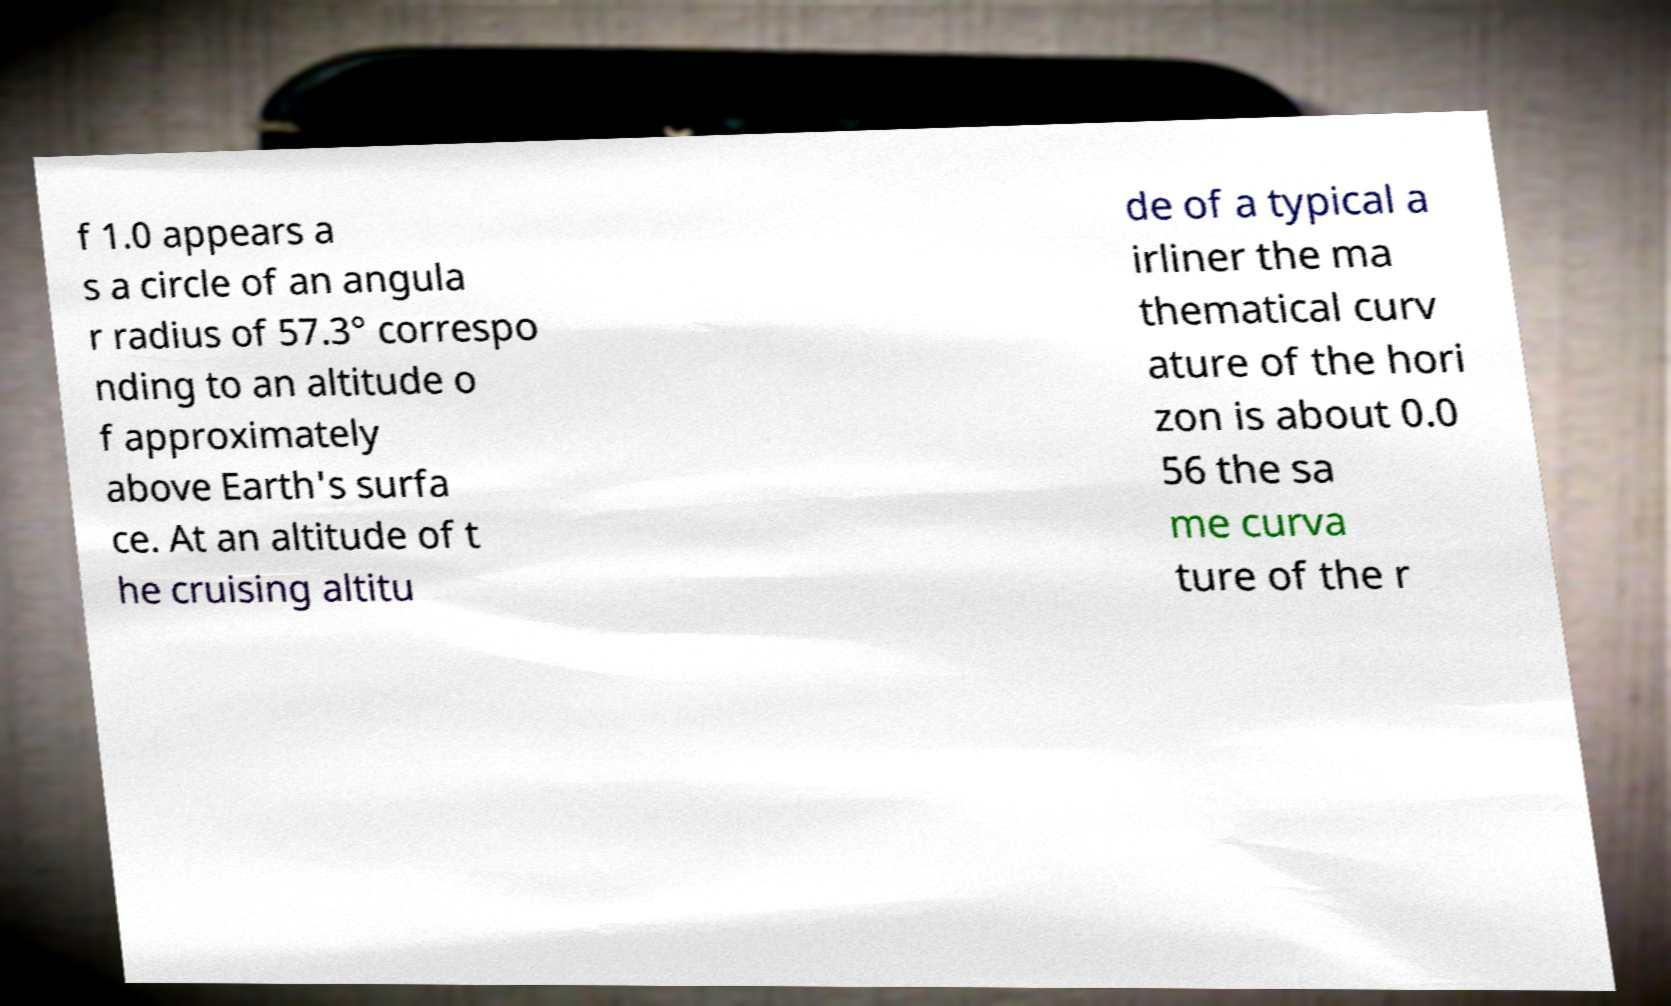Could you extract and type out the text from this image? f 1.0 appears a s a circle of an angula r radius of 57.3° correspo nding to an altitude o f approximately above Earth's surfa ce. At an altitude of t he cruising altitu de of a typical a irliner the ma thematical curv ature of the hori zon is about 0.0 56 the sa me curva ture of the r 